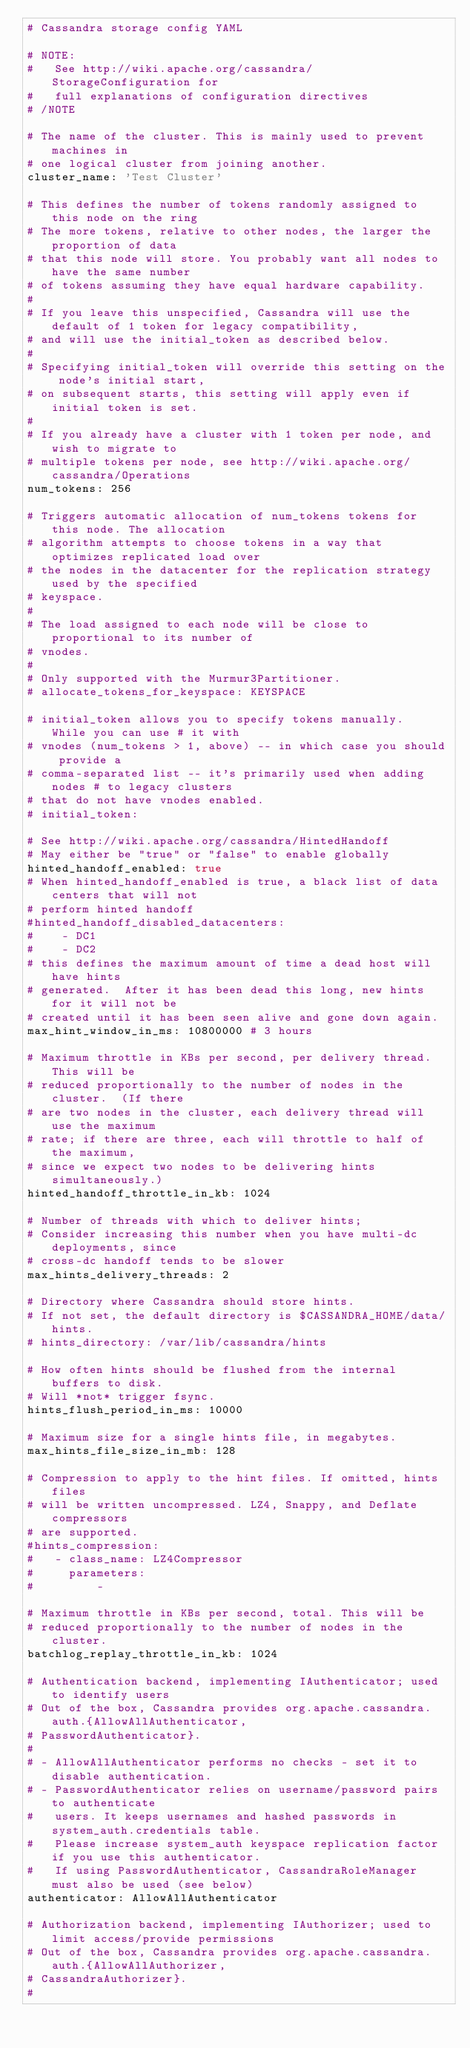Convert code to text. <code><loc_0><loc_0><loc_500><loc_500><_YAML_># Cassandra storage config YAML 

# NOTE:
#   See http://wiki.apache.org/cassandra/StorageConfiguration for
#   full explanations of configuration directives
# /NOTE

# The name of the cluster. This is mainly used to prevent machines in
# one logical cluster from joining another.
cluster_name: 'Test Cluster'

# This defines the number of tokens randomly assigned to this node on the ring
# The more tokens, relative to other nodes, the larger the proportion of data
# that this node will store. You probably want all nodes to have the same number
# of tokens assuming they have equal hardware capability.
#
# If you leave this unspecified, Cassandra will use the default of 1 token for legacy compatibility,
# and will use the initial_token as described below.
#
# Specifying initial_token will override this setting on the node's initial start,
# on subsequent starts, this setting will apply even if initial token is set.
#
# If you already have a cluster with 1 token per node, and wish to migrate to 
# multiple tokens per node, see http://wiki.apache.org/cassandra/Operations
num_tokens: 256

# Triggers automatic allocation of num_tokens tokens for this node. The allocation
# algorithm attempts to choose tokens in a way that optimizes replicated load over
# the nodes in the datacenter for the replication strategy used by the specified
# keyspace.
#
# The load assigned to each node will be close to proportional to its number of
# vnodes.
#
# Only supported with the Murmur3Partitioner.
# allocate_tokens_for_keyspace: KEYSPACE

# initial_token allows you to specify tokens manually.  While you can use # it with
# vnodes (num_tokens > 1, above) -- in which case you should provide a 
# comma-separated list -- it's primarily used when adding nodes # to legacy clusters 
# that do not have vnodes enabled.
# initial_token:

# See http://wiki.apache.org/cassandra/HintedHandoff
# May either be "true" or "false" to enable globally
hinted_handoff_enabled: true
# When hinted_handoff_enabled is true, a black list of data centers that will not
# perform hinted handoff
#hinted_handoff_disabled_datacenters:
#    - DC1
#    - DC2
# this defines the maximum amount of time a dead host will have hints
# generated.  After it has been dead this long, new hints for it will not be
# created until it has been seen alive and gone down again.
max_hint_window_in_ms: 10800000 # 3 hours

# Maximum throttle in KBs per second, per delivery thread.  This will be
# reduced proportionally to the number of nodes in the cluster.  (If there
# are two nodes in the cluster, each delivery thread will use the maximum
# rate; if there are three, each will throttle to half of the maximum,
# since we expect two nodes to be delivering hints simultaneously.)
hinted_handoff_throttle_in_kb: 1024

# Number of threads with which to deliver hints;
# Consider increasing this number when you have multi-dc deployments, since
# cross-dc handoff tends to be slower
max_hints_delivery_threads: 2

# Directory where Cassandra should store hints.
# If not set, the default directory is $CASSANDRA_HOME/data/hints.
# hints_directory: /var/lib/cassandra/hints

# How often hints should be flushed from the internal buffers to disk.
# Will *not* trigger fsync.
hints_flush_period_in_ms: 10000

# Maximum size for a single hints file, in megabytes.
max_hints_file_size_in_mb: 128

# Compression to apply to the hint files. If omitted, hints files
# will be written uncompressed. LZ4, Snappy, and Deflate compressors
# are supported.
#hints_compression:
#   - class_name: LZ4Compressor
#     parameters:
#         -

# Maximum throttle in KBs per second, total. This will be
# reduced proportionally to the number of nodes in the cluster.
batchlog_replay_throttle_in_kb: 1024

# Authentication backend, implementing IAuthenticator; used to identify users
# Out of the box, Cassandra provides org.apache.cassandra.auth.{AllowAllAuthenticator,
# PasswordAuthenticator}.
#
# - AllowAllAuthenticator performs no checks - set it to disable authentication.
# - PasswordAuthenticator relies on username/password pairs to authenticate
#   users. It keeps usernames and hashed passwords in system_auth.credentials table.
#   Please increase system_auth keyspace replication factor if you use this authenticator.
#   If using PasswordAuthenticator, CassandraRoleManager must also be used (see below)
authenticator: AllowAllAuthenticator

# Authorization backend, implementing IAuthorizer; used to limit access/provide permissions
# Out of the box, Cassandra provides org.apache.cassandra.auth.{AllowAllAuthorizer,
# CassandraAuthorizer}.
#</code> 